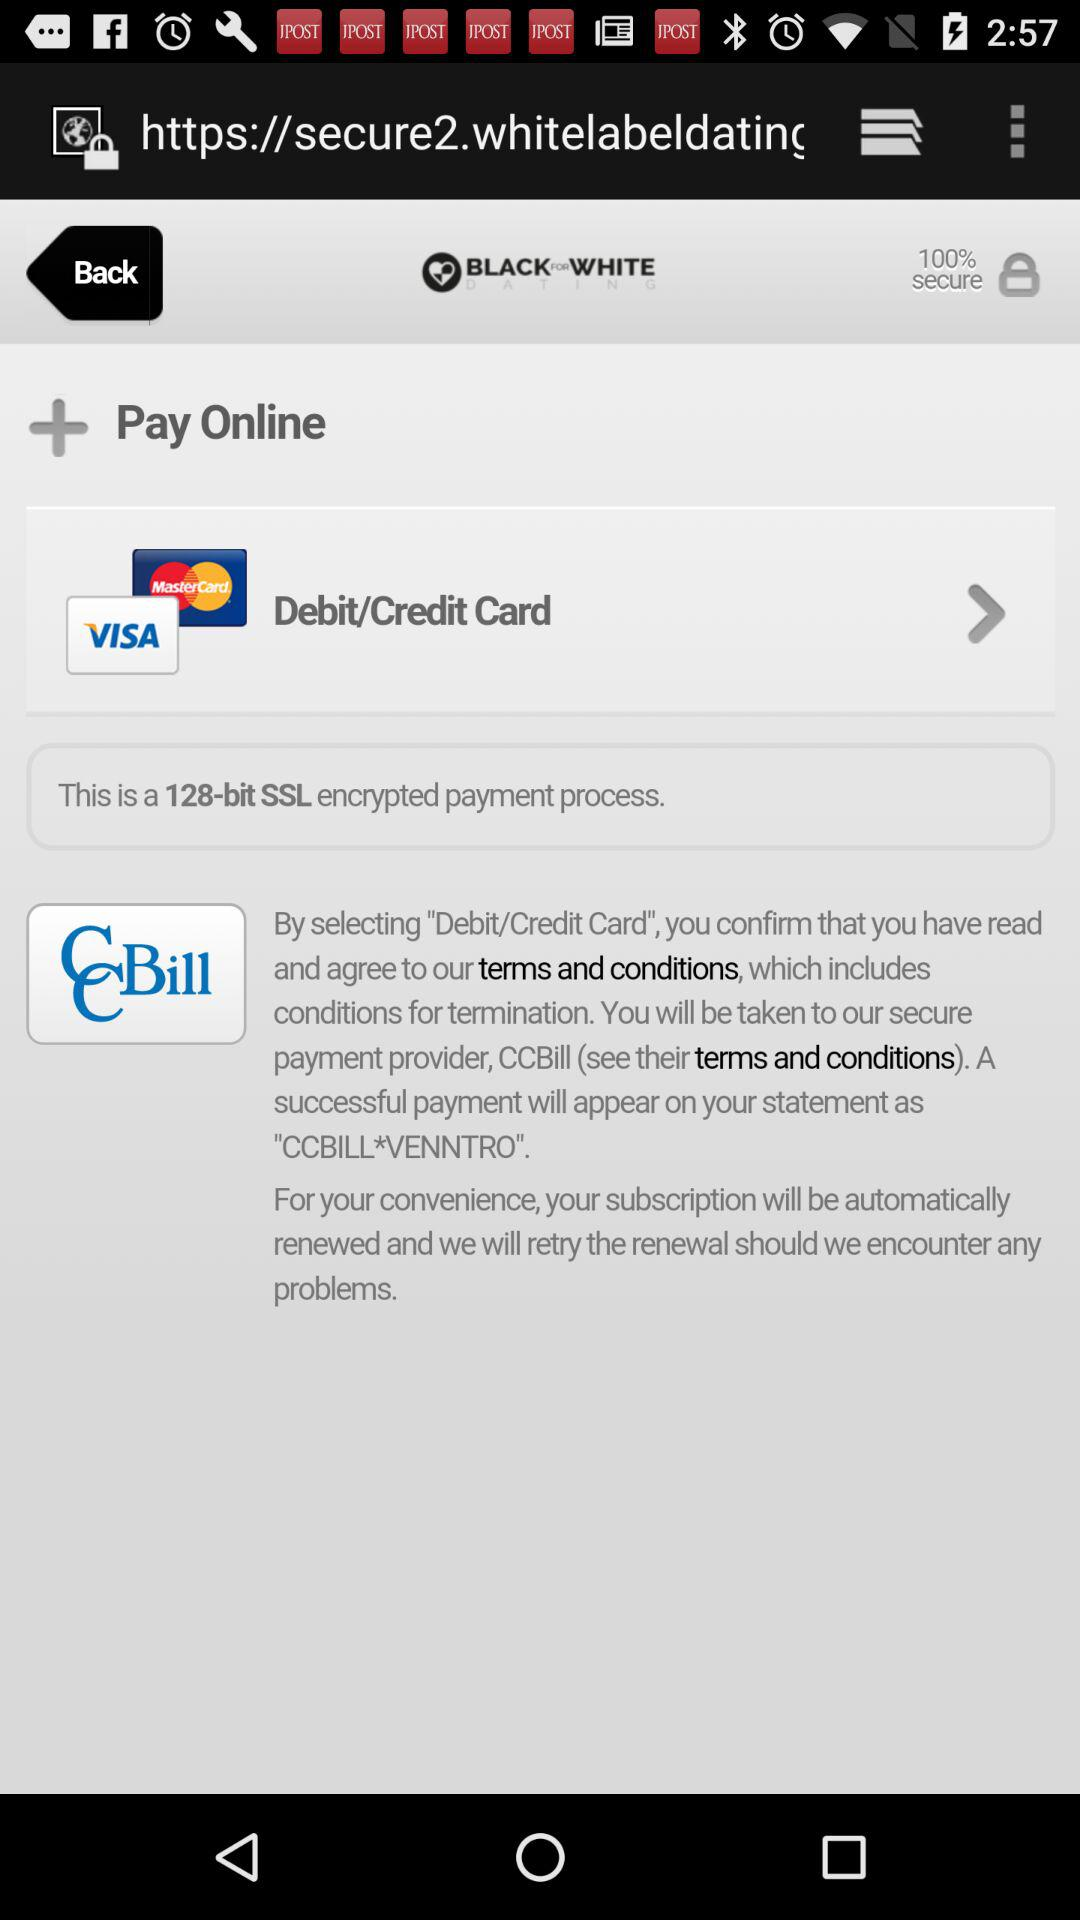What is the name? The name is Sam. 